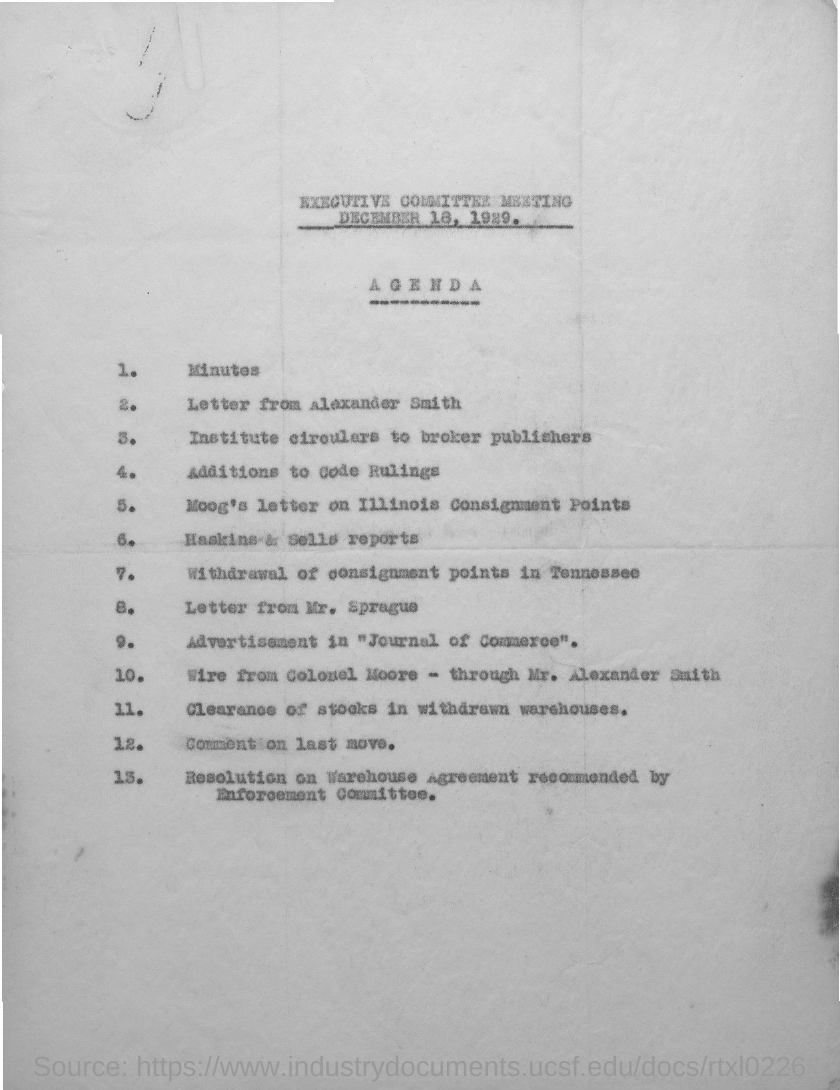List a handful of essential elements in this visual. The agenda number 1 is 'Minutes'. 